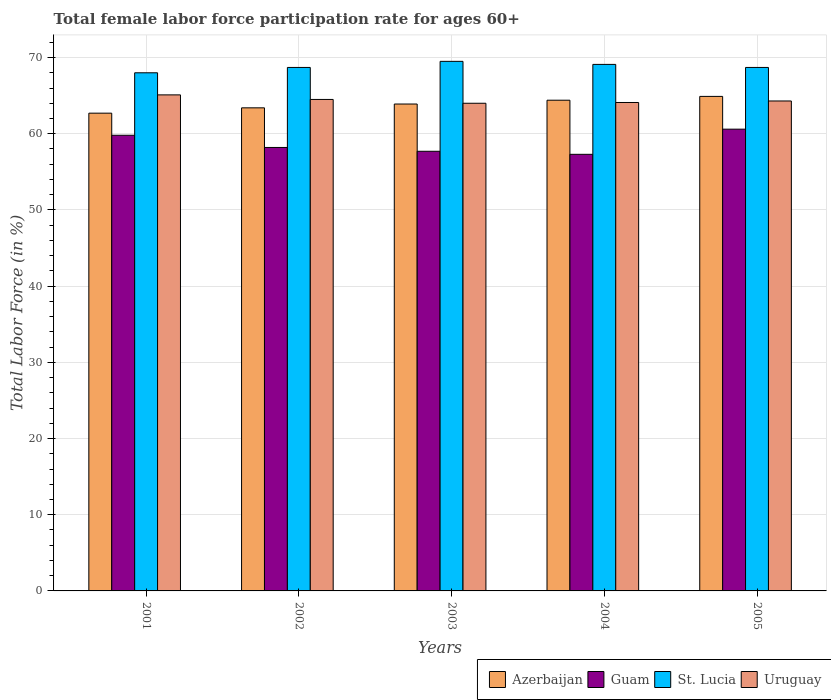Are the number of bars per tick equal to the number of legend labels?
Offer a terse response. Yes. What is the label of the 5th group of bars from the left?
Give a very brief answer. 2005. What is the female labor force participation rate in Guam in 2001?
Keep it short and to the point. 59.8. Across all years, what is the maximum female labor force participation rate in St. Lucia?
Keep it short and to the point. 69.5. Across all years, what is the minimum female labor force participation rate in Azerbaijan?
Your answer should be compact. 62.7. In which year was the female labor force participation rate in Guam minimum?
Give a very brief answer. 2004. What is the total female labor force participation rate in St. Lucia in the graph?
Keep it short and to the point. 344. What is the difference between the female labor force participation rate in St. Lucia in 2004 and that in 2005?
Offer a very short reply. 0.4. What is the difference between the female labor force participation rate in Guam in 2001 and the female labor force participation rate in St. Lucia in 2004?
Offer a terse response. -9.3. What is the average female labor force participation rate in Uruguay per year?
Your answer should be compact. 64.4. In the year 2004, what is the difference between the female labor force participation rate in Uruguay and female labor force participation rate in Azerbaijan?
Your answer should be compact. -0.3. What is the ratio of the female labor force participation rate in Guam in 2001 to that in 2004?
Give a very brief answer. 1.04. Is the difference between the female labor force participation rate in Uruguay in 2002 and 2005 greater than the difference between the female labor force participation rate in Azerbaijan in 2002 and 2005?
Provide a short and direct response. Yes. What is the difference between the highest and the second highest female labor force participation rate in St. Lucia?
Your response must be concise. 0.4. What is the difference between the highest and the lowest female labor force participation rate in Guam?
Give a very brief answer. 3.3. In how many years, is the female labor force participation rate in Guam greater than the average female labor force participation rate in Guam taken over all years?
Make the answer very short. 2. Is it the case that in every year, the sum of the female labor force participation rate in Azerbaijan and female labor force participation rate in Uruguay is greater than the sum of female labor force participation rate in Guam and female labor force participation rate in St. Lucia?
Provide a short and direct response. No. What does the 4th bar from the left in 2001 represents?
Keep it short and to the point. Uruguay. What does the 3rd bar from the right in 2003 represents?
Ensure brevity in your answer.  Guam. How many bars are there?
Your response must be concise. 20. Are all the bars in the graph horizontal?
Your answer should be compact. No. What is the difference between two consecutive major ticks on the Y-axis?
Your answer should be compact. 10. Are the values on the major ticks of Y-axis written in scientific E-notation?
Provide a succinct answer. No. Does the graph contain any zero values?
Ensure brevity in your answer.  No. Where does the legend appear in the graph?
Your answer should be compact. Bottom right. How many legend labels are there?
Give a very brief answer. 4. How are the legend labels stacked?
Ensure brevity in your answer.  Horizontal. What is the title of the graph?
Make the answer very short. Total female labor force participation rate for ages 60+. Does "Turkey" appear as one of the legend labels in the graph?
Your answer should be very brief. No. What is the label or title of the X-axis?
Give a very brief answer. Years. What is the Total Labor Force (in %) of Azerbaijan in 2001?
Make the answer very short. 62.7. What is the Total Labor Force (in %) in Guam in 2001?
Offer a very short reply. 59.8. What is the Total Labor Force (in %) of St. Lucia in 2001?
Make the answer very short. 68. What is the Total Labor Force (in %) of Uruguay in 2001?
Provide a short and direct response. 65.1. What is the Total Labor Force (in %) in Azerbaijan in 2002?
Provide a short and direct response. 63.4. What is the Total Labor Force (in %) in Guam in 2002?
Your answer should be very brief. 58.2. What is the Total Labor Force (in %) of St. Lucia in 2002?
Your response must be concise. 68.7. What is the Total Labor Force (in %) in Uruguay in 2002?
Keep it short and to the point. 64.5. What is the Total Labor Force (in %) of Azerbaijan in 2003?
Provide a succinct answer. 63.9. What is the Total Labor Force (in %) in Guam in 2003?
Keep it short and to the point. 57.7. What is the Total Labor Force (in %) of St. Lucia in 2003?
Provide a succinct answer. 69.5. What is the Total Labor Force (in %) of Azerbaijan in 2004?
Ensure brevity in your answer.  64.4. What is the Total Labor Force (in %) of Guam in 2004?
Offer a terse response. 57.3. What is the Total Labor Force (in %) of St. Lucia in 2004?
Give a very brief answer. 69.1. What is the Total Labor Force (in %) in Uruguay in 2004?
Offer a terse response. 64.1. What is the Total Labor Force (in %) of Azerbaijan in 2005?
Make the answer very short. 64.9. What is the Total Labor Force (in %) of Guam in 2005?
Make the answer very short. 60.6. What is the Total Labor Force (in %) of St. Lucia in 2005?
Your answer should be very brief. 68.7. What is the Total Labor Force (in %) of Uruguay in 2005?
Keep it short and to the point. 64.3. Across all years, what is the maximum Total Labor Force (in %) in Azerbaijan?
Ensure brevity in your answer.  64.9. Across all years, what is the maximum Total Labor Force (in %) of Guam?
Your answer should be very brief. 60.6. Across all years, what is the maximum Total Labor Force (in %) of St. Lucia?
Your response must be concise. 69.5. Across all years, what is the maximum Total Labor Force (in %) in Uruguay?
Your answer should be compact. 65.1. Across all years, what is the minimum Total Labor Force (in %) in Azerbaijan?
Your answer should be compact. 62.7. Across all years, what is the minimum Total Labor Force (in %) of Guam?
Offer a terse response. 57.3. Across all years, what is the minimum Total Labor Force (in %) of St. Lucia?
Ensure brevity in your answer.  68. Across all years, what is the minimum Total Labor Force (in %) in Uruguay?
Ensure brevity in your answer.  64. What is the total Total Labor Force (in %) in Azerbaijan in the graph?
Provide a succinct answer. 319.3. What is the total Total Labor Force (in %) of Guam in the graph?
Keep it short and to the point. 293.6. What is the total Total Labor Force (in %) in St. Lucia in the graph?
Your response must be concise. 344. What is the total Total Labor Force (in %) in Uruguay in the graph?
Provide a succinct answer. 322. What is the difference between the Total Labor Force (in %) in Guam in 2001 and that in 2002?
Offer a very short reply. 1.6. What is the difference between the Total Labor Force (in %) of Uruguay in 2001 and that in 2002?
Your response must be concise. 0.6. What is the difference between the Total Labor Force (in %) in Azerbaijan in 2001 and that in 2003?
Your response must be concise. -1.2. What is the difference between the Total Labor Force (in %) in St. Lucia in 2001 and that in 2003?
Your answer should be very brief. -1.5. What is the difference between the Total Labor Force (in %) of Uruguay in 2001 and that in 2003?
Keep it short and to the point. 1.1. What is the difference between the Total Labor Force (in %) of Azerbaijan in 2001 and that in 2004?
Provide a short and direct response. -1.7. What is the difference between the Total Labor Force (in %) of Guam in 2001 and that in 2004?
Your answer should be compact. 2.5. What is the difference between the Total Labor Force (in %) of St. Lucia in 2001 and that in 2004?
Your answer should be very brief. -1.1. What is the difference between the Total Labor Force (in %) in Uruguay in 2001 and that in 2005?
Offer a terse response. 0.8. What is the difference between the Total Labor Force (in %) in St. Lucia in 2002 and that in 2003?
Keep it short and to the point. -0.8. What is the difference between the Total Labor Force (in %) of Guam in 2002 and that in 2004?
Keep it short and to the point. 0.9. What is the difference between the Total Labor Force (in %) in St. Lucia in 2002 and that in 2004?
Give a very brief answer. -0.4. What is the difference between the Total Labor Force (in %) in Uruguay in 2002 and that in 2004?
Your response must be concise. 0.4. What is the difference between the Total Labor Force (in %) in Guam in 2002 and that in 2005?
Ensure brevity in your answer.  -2.4. What is the difference between the Total Labor Force (in %) of St. Lucia in 2002 and that in 2005?
Your answer should be compact. 0. What is the difference between the Total Labor Force (in %) of Uruguay in 2002 and that in 2005?
Your answer should be very brief. 0.2. What is the difference between the Total Labor Force (in %) in Guam in 2003 and that in 2004?
Give a very brief answer. 0.4. What is the difference between the Total Labor Force (in %) in Uruguay in 2003 and that in 2004?
Offer a very short reply. -0.1. What is the difference between the Total Labor Force (in %) in Uruguay in 2004 and that in 2005?
Keep it short and to the point. -0.2. What is the difference between the Total Labor Force (in %) in Azerbaijan in 2001 and the Total Labor Force (in %) in St. Lucia in 2002?
Your answer should be compact. -6. What is the difference between the Total Labor Force (in %) of Azerbaijan in 2001 and the Total Labor Force (in %) of Uruguay in 2002?
Ensure brevity in your answer.  -1.8. What is the difference between the Total Labor Force (in %) in Azerbaijan in 2001 and the Total Labor Force (in %) in Guam in 2003?
Give a very brief answer. 5. What is the difference between the Total Labor Force (in %) in Azerbaijan in 2001 and the Total Labor Force (in %) in St. Lucia in 2003?
Keep it short and to the point. -6.8. What is the difference between the Total Labor Force (in %) of St. Lucia in 2001 and the Total Labor Force (in %) of Uruguay in 2003?
Make the answer very short. 4. What is the difference between the Total Labor Force (in %) of Azerbaijan in 2001 and the Total Labor Force (in %) of Guam in 2004?
Your answer should be very brief. 5.4. What is the difference between the Total Labor Force (in %) in Azerbaijan in 2001 and the Total Labor Force (in %) in St. Lucia in 2004?
Keep it short and to the point. -6.4. What is the difference between the Total Labor Force (in %) in Azerbaijan in 2001 and the Total Labor Force (in %) in Uruguay in 2004?
Your response must be concise. -1.4. What is the difference between the Total Labor Force (in %) of Guam in 2001 and the Total Labor Force (in %) of St. Lucia in 2004?
Make the answer very short. -9.3. What is the difference between the Total Labor Force (in %) of St. Lucia in 2001 and the Total Labor Force (in %) of Uruguay in 2004?
Give a very brief answer. 3.9. What is the difference between the Total Labor Force (in %) of Guam in 2001 and the Total Labor Force (in %) of St. Lucia in 2005?
Your response must be concise. -8.9. What is the difference between the Total Labor Force (in %) of Azerbaijan in 2002 and the Total Labor Force (in %) of Guam in 2003?
Provide a succinct answer. 5.7. What is the difference between the Total Labor Force (in %) in Azerbaijan in 2002 and the Total Labor Force (in %) in St. Lucia in 2003?
Ensure brevity in your answer.  -6.1. What is the difference between the Total Labor Force (in %) in Guam in 2002 and the Total Labor Force (in %) in Uruguay in 2003?
Your answer should be compact. -5.8. What is the difference between the Total Labor Force (in %) in Guam in 2002 and the Total Labor Force (in %) in Uruguay in 2004?
Your response must be concise. -5.9. What is the difference between the Total Labor Force (in %) of St. Lucia in 2002 and the Total Labor Force (in %) of Uruguay in 2004?
Provide a succinct answer. 4.6. What is the difference between the Total Labor Force (in %) of Azerbaijan in 2002 and the Total Labor Force (in %) of Guam in 2005?
Provide a succinct answer. 2.8. What is the difference between the Total Labor Force (in %) in Azerbaijan in 2002 and the Total Labor Force (in %) in St. Lucia in 2005?
Offer a very short reply. -5.3. What is the difference between the Total Labor Force (in %) in Azerbaijan in 2002 and the Total Labor Force (in %) in Uruguay in 2005?
Keep it short and to the point. -0.9. What is the difference between the Total Labor Force (in %) in Guam in 2002 and the Total Labor Force (in %) in St. Lucia in 2005?
Provide a succinct answer. -10.5. What is the difference between the Total Labor Force (in %) in Guam in 2002 and the Total Labor Force (in %) in Uruguay in 2005?
Offer a terse response. -6.1. What is the difference between the Total Labor Force (in %) in Azerbaijan in 2003 and the Total Labor Force (in %) in St. Lucia in 2004?
Your answer should be compact. -5.2. What is the difference between the Total Labor Force (in %) of Guam in 2003 and the Total Labor Force (in %) of Uruguay in 2004?
Ensure brevity in your answer.  -6.4. What is the difference between the Total Labor Force (in %) of St. Lucia in 2003 and the Total Labor Force (in %) of Uruguay in 2004?
Give a very brief answer. 5.4. What is the difference between the Total Labor Force (in %) of Azerbaijan in 2003 and the Total Labor Force (in %) of Guam in 2005?
Offer a terse response. 3.3. What is the difference between the Total Labor Force (in %) of Azerbaijan in 2003 and the Total Labor Force (in %) of St. Lucia in 2005?
Offer a terse response. -4.8. What is the difference between the Total Labor Force (in %) in Azerbaijan in 2003 and the Total Labor Force (in %) in Uruguay in 2005?
Provide a short and direct response. -0.4. What is the difference between the Total Labor Force (in %) in Guam in 2003 and the Total Labor Force (in %) in Uruguay in 2005?
Give a very brief answer. -6.6. What is the difference between the Total Labor Force (in %) of St. Lucia in 2003 and the Total Labor Force (in %) of Uruguay in 2005?
Ensure brevity in your answer.  5.2. What is the difference between the Total Labor Force (in %) in Azerbaijan in 2004 and the Total Labor Force (in %) in Guam in 2005?
Offer a terse response. 3.8. What is the difference between the Total Labor Force (in %) of Azerbaijan in 2004 and the Total Labor Force (in %) of Uruguay in 2005?
Ensure brevity in your answer.  0.1. What is the difference between the Total Labor Force (in %) in Guam in 2004 and the Total Labor Force (in %) in St. Lucia in 2005?
Provide a succinct answer. -11.4. What is the difference between the Total Labor Force (in %) of Guam in 2004 and the Total Labor Force (in %) of Uruguay in 2005?
Give a very brief answer. -7. What is the difference between the Total Labor Force (in %) in St. Lucia in 2004 and the Total Labor Force (in %) in Uruguay in 2005?
Make the answer very short. 4.8. What is the average Total Labor Force (in %) of Azerbaijan per year?
Ensure brevity in your answer.  63.86. What is the average Total Labor Force (in %) of Guam per year?
Keep it short and to the point. 58.72. What is the average Total Labor Force (in %) of St. Lucia per year?
Your answer should be very brief. 68.8. What is the average Total Labor Force (in %) of Uruguay per year?
Your answer should be very brief. 64.4. In the year 2001, what is the difference between the Total Labor Force (in %) of Azerbaijan and Total Labor Force (in %) of Guam?
Ensure brevity in your answer.  2.9. In the year 2001, what is the difference between the Total Labor Force (in %) in Guam and Total Labor Force (in %) in St. Lucia?
Your answer should be very brief. -8.2. In the year 2001, what is the difference between the Total Labor Force (in %) of Guam and Total Labor Force (in %) of Uruguay?
Provide a succinct answer. -5.3. In the year 2001, what is the difference between the Total Labor Force (in %) in St. Lucia and Total Labor Force (in %) in Uruguay?
Provide a succinct answer. 2.9. In the year 2002, what is the difference between the Total Labor Force (in %) in Azerbaijan and Total Labor Force (in %) in St. Lucia?
Offer a terse response. -5.3. In the year 2002, what is the difference between the Total Labor Force (in %) of Azerbaijan and Total Labor Force (in %) of Uruguay?
Your response must be concise. -1.1. In the year 2002, what is the difference between the Total Labor Force (in %) of Guam and Total Labor Force (in %) of St. Lucia?
Ensure brevity in your answer.  -10.5. In the year 2002, what is the difference between the Total Labor Force (in %) in Guam and Total Labor Force (in %) in Uruguay?
Make the answer very short. -6.3. In the year 2003, what is the difference between the Total Labor Force (in %) in Azerbaijan and Total Labor Force (in %) in Guam?
Offer a very short reply. 6.2. In the year 2003, what is the difference between the Total Labor Force (in %) of Azerbaijan and Total Labor Force (in %) of St. Lucia?
Provide a short and direct response. -5.6. In the year 2003, what is the difference between the Total Labor Force (in %) in Guam and Total Labor Force (in %) in St. Lucia?
Offer a very short reply. -11.8. In the year 2003, what is the difference between the Total Labor Force (in %) in St. Lucia and Total Labor Force (in %) in Uruguay?
Your answer should be compact. 5.5. In the year 2004, what is the difference between the Total Labor Force (in %) of Azerbaijan and Total Labor Force (in %) of Uruguay?
Your response must be concise. 0.3. In the year 2004, what is the difference between the Total Labor Force (in %) in Guam and Total Labor Force (in %) in St. Lucia?
Keep it short and to the point. -11.8. What is the ratio of the Total Labor Force (in %) in Azerbaijan in 2001 to that in 2002?
Your response must be concise. 0.99. What is the ratio of the Total Labor Force (in %) in Guam in 2001 to that in 2002?
Give a very brief answer. 1.03. What is the ratio of the Total Labor Force (in %) of St. Lucia in 2001 to that in 2002?
Provide a succinct answer. 0.99. What is the ratio of the Total Labor Force (in %) in Uruguay in 2001 to that in 2002?
Your response must be concise. 1.01. What is the ratio of the Total Labor Force (in %) of Azerbaijan in 2001 to that in 2003?
Give a very brief answer. 0.98. What is the ratio of the Total Labor Force (in %) of Guam in 2001 to that in 2003?
Offer a very short reply. 1.04. What is the ratio of the Total Labor Force (in %) in St. Lucia in 2001 to that in 2003?
Keep it short and to the point. 0.98. What is the ratio of the Total Labor Force (in %) in Uruguay in 2001 to that in 2003?
Provide a short and direct response. 1.02. What is the ratio of the Total Labor Force (in %) of Azerbaijan in 2001 to that in 2004?
Offer a very short reply. 0.97. What is the ratio of the Total Labor Force (in %) in Guam in 2001 to that in 2004?
Offer a terse response. 1.04. What is the ratio of the Total Labor Force (in %) in St. Lucia in 2001 to that in 2004?
Offer a terse response. 0.98. What is the ratio of the Total Labor Force (in %) of Uruguay in 2001 to that in 2004?
Give a very brief answer. 1.02. What is the ratio of the Total Labor Force (in %) of Azerbaijan in 2001 to that in 2005?
Provide a short and direct response. 0.97. What is the ratio of the Total Labor Force (in %) of Guam in 2001 to that in 2005?
Keep it short and to the point. 0.99. What is the ratio of the Total Labor Force (in %) in Uruguay in 2001 to that in 2005?
Ensure brevity in your answer.  1.01. What is the ratio of the Total Labor Force (in %) in Guam in 2002 to that in 2003?
Give a very brief answer. 1.01. What is the ratio of the Total Labor Force (in %) in St. Lucia in 2002 to that in 2003?
Offer a terse response. 0.99. What is the ratio of the Total Labor Force (in %) of Azerbaijan in 2002 to that in 2004?
Your response must be concise. 0.98. What is the ratio of the Total Labor Force (in %) in Guam in 2002 to that in 2004?
Offer a very short reply. 1.02. What is the ratio of the Total Labor Force (in %) of St. Lucia in 2002 to that in 2004?
Your answer should be very brief. 0.99. What is the ratio of the Total Labor Force (in %) of Uruguay in 2002 to that in 2004?
Give a very brief answer. 1.01. What is the ratio of the Total Labor Force (in %) in Azerbaijan in 2002 to that in 2005?
Offer a very short reply. 0.98. What is the ratio of the Total Labor Force (in %) in Guam in 2002 to that in 2005?
Offer a terse response. 0.96. What is the ratio of the Total Labor Force (in %) in St. Lucia in 2002 to that in 2005?
Provide a short and direct response. 1. What is the ratio of the Total Labor Force (in %) in St. Lucia in 2003 to that in 2004?
Your response must be concise. 1.01. What is the ratio of the Total Labor Force (in %) in Uruguay in 2003 to that in 2004?
Your answer should be very brief. 1. What is the ratio of the Total Labor Force (in %) of Azerbaijan in 2003 to that in 2005?
Ensure brevity in your answer.  0.98. What is the ratio of the Total Labor Force (in %) of Guam in 2003 to that in 2005?
Your answer should be very brief. 0.95. What is the ratio of the Total Labor Force (in %) of St. Lucia in 2003 to that in 2005?
Offer a terse response. 1.01. What is the ratio of the Total Labor Force (in %) in Azerbaijan in 2004 to that in 2005?
Make the answer very short. 0.99. What is the ratio of the Total Labor Force (in %) of Guam in 2004 to that in 2005?
Make the answer very short. 0.95. What is the ratio of the Total Labor Force (in %) of St. Lucia in 2004 to that in 2005?
Keep it short and to the point. 1.01. What is the ratio of the Total Labor Force (in %) in Uruguay in 2004 to that in 2005?
Your answer should be very brief. 1. What is the difference between the highest and the second highest Total Labor Force (in %) in Guam?
Ensure brevity in your answer.  0.8. What is the difference between the highest and the second highest Total Labor Force (in %) in St. Lucia?
Offer a very short reply. 0.4. What is the difference between the highest and the lowest Total Labor Force (in %) of Guam?
Keep it short and to the point. 3.3. What is the difference between the highest and the lowest Total Labor Force (in %) in Uruguay?
Provide a succinct answer. 1.1. 